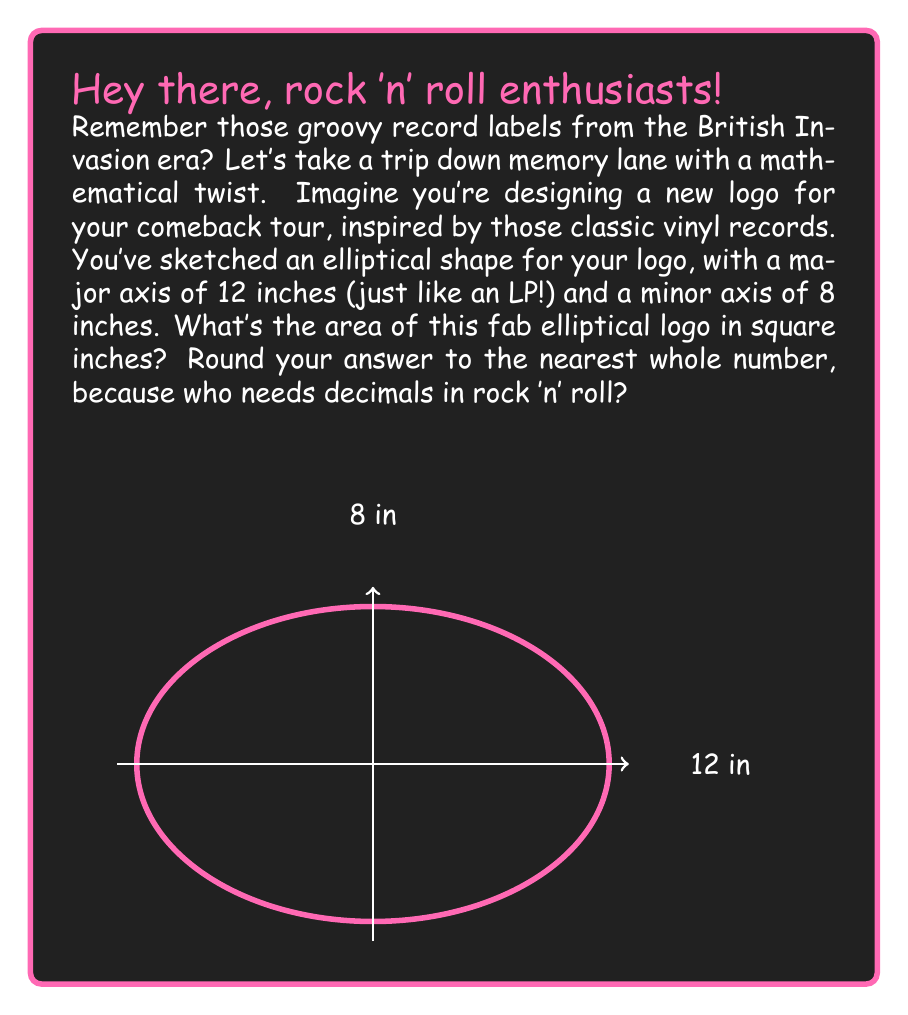Solve this math problem. Alright, let's break this down like a classic rock anthem:

1) The formula for the area of an ellipse is:
   $$A = \pi ab$$
   where $a$ is half the length of the major axis and $b$ is half the length of the minor axis.

2) In our groovy logo:
   - Major axis = 12 inches, so $a = 6$ inches
   - Minor axis = 8 inches, so $b = 4$ inches

3) Let's plug these into our formula:
   $$A = \pi (6)(4)$$

4) Simplify:
   $$A = 24\pi$$

5) Now, let's calculate this (using 3.14159 for $\pi$):
   $$A = 24 * 3.14159 = 75.39816$$

6) Rounding to the nearest whole number (because rock 'n' roll doesn't do decimals):
   $$A \approx 75$$

And there you have it! Your elliptical logo area is as cool as a 75 square inch vinyl record.
Answer: 75 square inches 